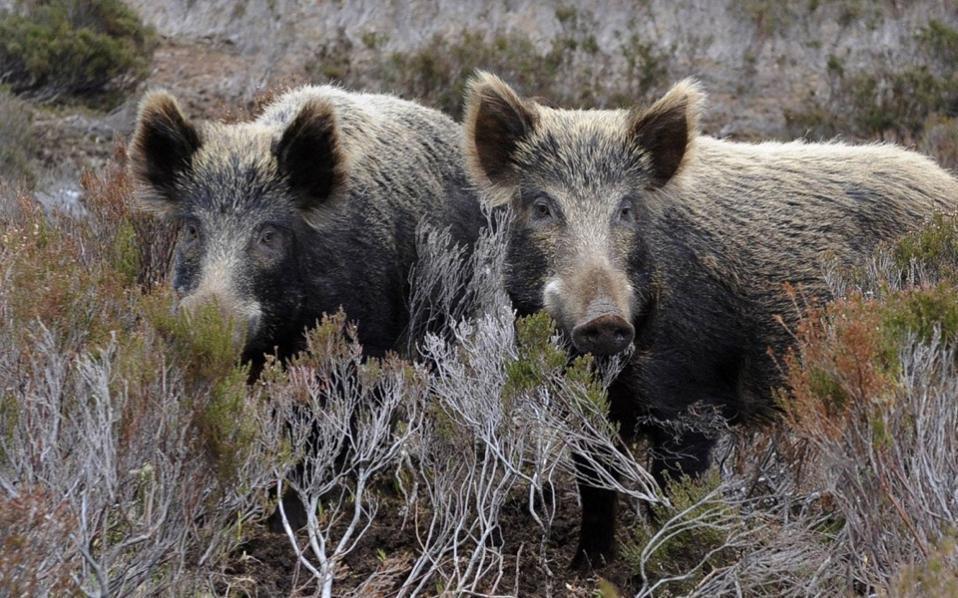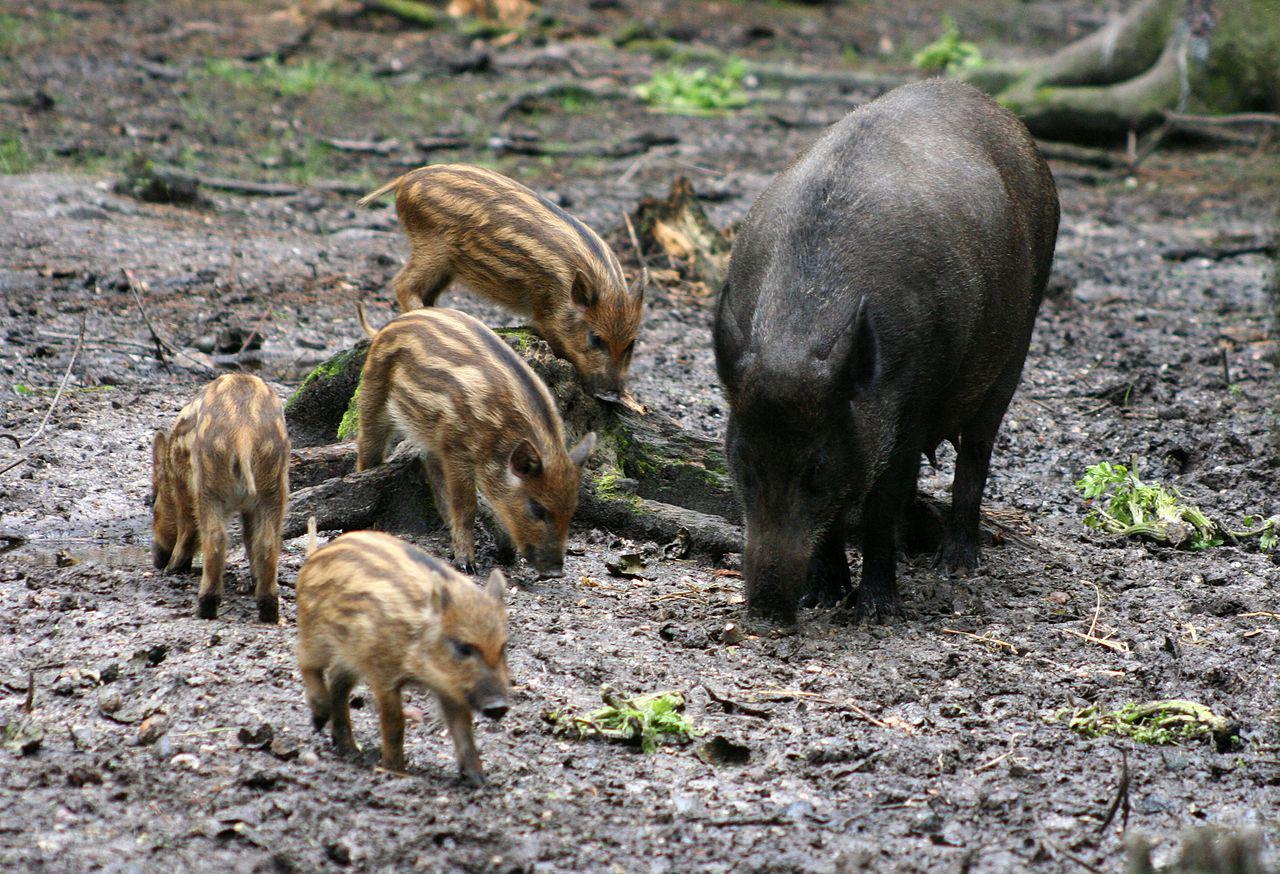The first image is the image on the left, the second image is the image on the right. Given the left and right images, does the statement "A wild boar is lying on the ground in the image on the right." hold true? Answer yes or no. No. The first image is the image on the left, the second image is the image on the right. For the images shown, is this caption "The combined images contain only standing pigs, including at least three lighter-colored piglets and at least three bigger adult pigs." true? Answer yes or no. Yes. 